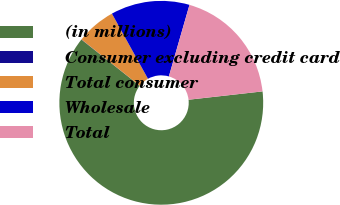Convert chart. <chart><loc_0><loc_0><loc_500><loc_500><pie_chart><fcel>(in millions)<fcel>Consumer excluding credit card<fcel>Total consumer<fcel>Wholesale<fcel>Total<nl><fcel>62.43%<fcel>0.03%<fcel>6.27%<fcel>12.51%<fcel>18.75%<nl></chart> 